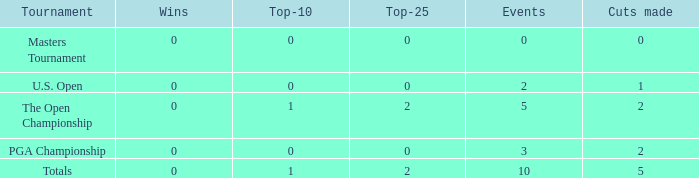In events with one or more wins, what is the accumulated amount of top-10 positions? None. 